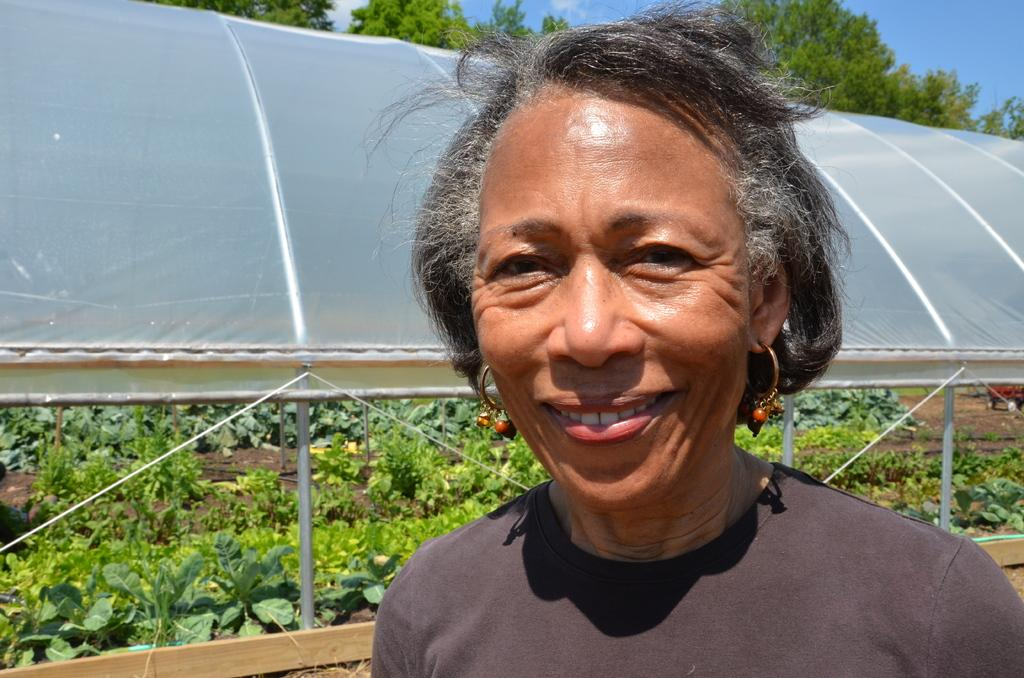Who is the main subject in the foreground of the image? There is a lady in the foreground of the image. What structure can be seen in the background of the image? There is a shed in the background of the image. What type of vegetation is present in the image? There are plants in the image. What else can be seen in the background of the image? There are trees in the background of the image. What news is the lady reading in the image? There is no indication in the image that the lady is reading any news. How many bears are visible in the image? There are no bears present in the image. 